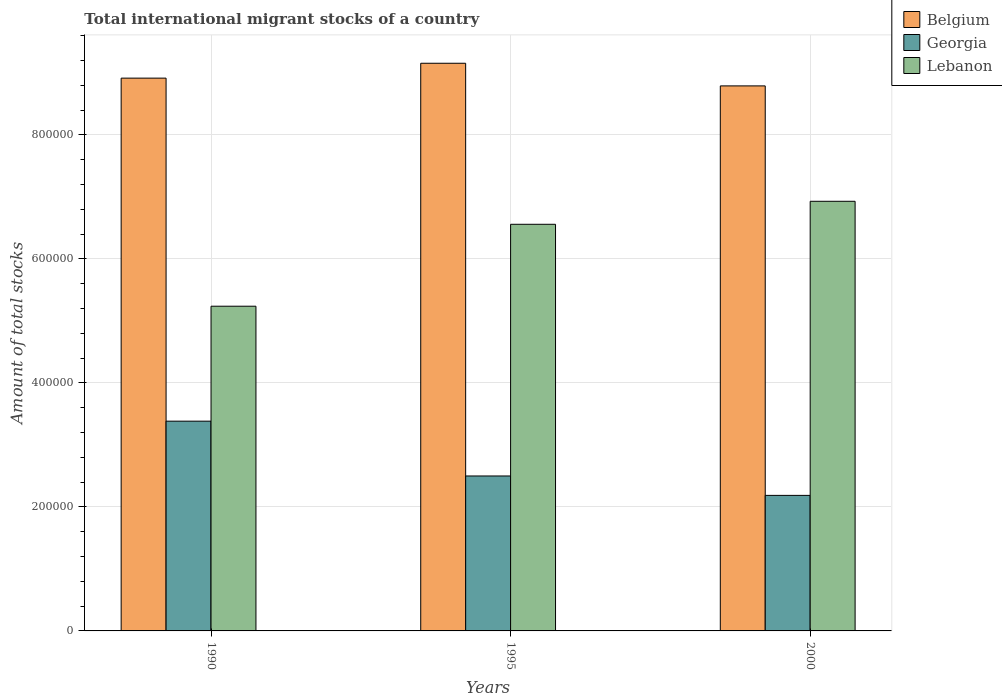Are the number of bars on each tick of the X-axis equal?
Your answer should be compact. Yes. How many bars are there on the 1st tick from the left?
Provide a succinct answer. 3. In how many cases, is the number of bars for a given year not equal to the number of legend labels?
Provide a short and direct response. 0. What is the amount of total stocks in in Georgia in 1995?
Your answer should be compact. 2.50e+05. Across all years, what is the maximum amount of total stocks in in Belgium?
Ensure brevity in your answer.  9.16e+05. Across all years, what is the minimum amount of total stocks in in Georgia?
Give a very brief answer. 2.19e+05. What is the total amount of total stocks in in Belgium in the graph?
Your answer should be compact. 2.69e+06. What is the difference between the amount of total stocks in in Belgium in 1990 and that in 1995?
Offer a very short reply. -2.40e+04. What is the difference between the amount of total stocks in in Lebanon in 1995 and the amount of total stocks in in Belgium in 1990?
Your response must be concise. -2.36e+05. What is the average amount of total stocks in in Lebanon per year?
Ensure brevity in your answer.  6.24e+05. In the year 2000, what is the difference between the amount of total stocks in in Belgium and amount of total stocks in in Georgia?
Your answer should be compact. 6.60e+05. What is the ratio of the amount of total stocks in in Lebanon in 1995 to that in 2000?
Offer a terse response. 0.95. Is the amount of total stocks in in Lebanon in 1995 less than that in 2000?
Ensure brevity in your answer.  Yes. What is the difference between the highest and the second highest amount of total stocks in in Belgium?
Provide a short and direct response. 2.40e+04. What is the difference between the highest and the lowest amount of total stocks in in Belgium?
Offer a terse response. 3.65e+04. In how many years, is the amount of total stocks in in Lebanon greater than the average amount of total stocks in in Lebanon taken over all years?
Your answer should be very brief. 2. What does the 2nd bar from the right in 2000 represents?
Your answer should be very brief. Georgia. How many bars are there?
Offer a very short reply. 9. Are the values on the major ticks of Y-axis written in scientific E-notation?
Your answer should be very brief. No. Does the graph contain any zero values?
Your response must be concise. No. How many legend labels are there?
Ensure brevity in your answer.  3. How are the legend labels stacked?
Give a very brief answer. Vertical. What is the title of the graph?
Your answer should be very brief. Total international migrant stocks of a country. Does "St. Vincent and the Grenadines" appear as one of the legend labels in the graph?
Provide a succinct answer. No. What is the label or title of the Y-axis?
Provide a succinct answer. Amount of total stocks. What is the Amount of total stocks in Belgium in 1990?
Keep it short and to the point. 8.92e+05. What is the Amount of total stocks of Georgia in 1990?
Provide a succinct answer. 3.38e+05. What is the Amount of total stocks in Lebanon in 1990?
Provide a short and direct response. 5.24e+05. What is the Amount of total stocks in Belgium in 1995?
Ensure brevity in your answer.  9.16e+05. What is the Amount of total stocks in Georgia in 1995?
Offer a very short reply. 2.50e+05. What is the Amount of total stocks of Lebanon in 1995?
Give a very brief answer. 6.56e+05. What is the Amount of total stocks of Belgium in 2000?
Your answer should be very brief. 8.79e+05. What is the Amount of total stocks of Georgia in 2000?
Give a very brief answer. 2.19e+05. What is the Amount of total stocks of Lebanon in 2000?
Make the answer very short. 6.93e+05. Across all years, what is the maximum Amount of total stocks in Belgium?
Keep it short and to the point. 9.16e+05. Across all years, what is the maximum Amount of total stocks of Georgia?
Provide a short and direct response. 3.38e+05. Across all years, what is the maximum Amount of total stocks in Lebanon?
Offer a very short reply. 6.93e+05. Across all years, what is the minimum Amount of total stocks in Belgium?
Ensure brevity in your answer.  8.79e+05. Across all years, what is the minimum Amount of total stocks in Georgia?
Your response must be concise. 2.19e+05. Across all years, what is the minimum Amount of total stocks in Lebanon?
Your response must be concise. 5.24e+05. What is the total Amount of total stocks in Belgium in the graph?
Ensure brevity in your answer.  2.69e+06. What is the total Amount of total stocks in Georgia in the graph?
Give a very brief answer. 8.07e+05. What is the total Amount of total stocks in Lebanon in the graph?
Provide a succinct answer. 1.87e+06. What is the difference between the Amount of total stocks in Belgium in 1990 and that in 1995?
Provide a short and direct response. -2.40e+04. What is the difference between the Amount of total stocks in Georgia in 1990 and that in 1995?
Your answer should be compact. 8.84e+04. What is the difference between the Amount of total stocks of Lebanon in 1990 and that in 1995?
Keep it short and to the point. -1.32e+05. What is the difference between the Amount of total stocks in Belgium in 1990 and that in 2000?
Offer a terse response. 1.25e+04. What is the difference between the Amount of total stocks in Georgia in 1990 and that in 2000?
Make the answer very short. 1.20e+05. What is the difference between the Amount of total stocks of Lebanon in 1990 and that in 2000?
Your answer should be very brief. -1.69e+05. What is the difference between the Amount of total stocks in Belgium in 1995 and that in 2000?
Your answer should be very brief. 3.65e+04. What is the difference between the Amount of total stocks of Georgia in 1995 and that in 2000?
Your answer should be very brief. 3.13e+04. What is the difference between the Amount of total stocks in Lebanon in 1995 and that in 2000?
Provide a succinct answer. -3.71e+04. What is the difference between the Amount of total stocks of Belgium in 1990 and the Amount of total stocks of Georgia in 1995?
Provide a succinct answer. 6.42e+05. What is the difference between the Amount of total stocks in Belgium in 1990 and the Amount of total stocks in Lebanon in 1995?
Ensure brevity in your answer.  2.36e+05. What is the difference between the Amount of total stocks in Georgia in 1990 and the Amount of total stocks in Lebanon in 1995?
Your answer should be compact. -3.18e+05. What is the difference between the Amount of total stocks of Belgium in 1990 and the Amount of total stocks of Georgia in 2000?
Provide a succinct answer. 6.73e+05. What is the difference between the Amount of total stocks of Belgium in 1990 and the Amount of total stocks of Lebanon in 2000?
Your answer should be compact. 1.99e+05. What is the difference between the Amount of total stocks of Georgia in 1990 and the Amount of total stocks of Lebanon in 2000?
Keep it short and to the point. -3.55e+05. What is the difference between the Amount of total stocks of Belgium in 1995 and the Amount of total stocks of Georgia in 2000?
Give a very brief answer. 6.97e+05. What is the difference between the Amount of total stocks in Belgium in 1995 and the Amount of total stocks in Lebanon in 2000?
Offer a very short reply. 2.23e+05. What is the difference between the Amount of total stocks of Georgia in 1995 and the Amount of total stocks of Lebanon in 2000?
Provide a succinct answer. -4.43e+05. What is the average Amount of total stocks of Belgium per year?
Your answer should be compact. 8.95e+05. What is the average Amount of total stocks of Georgia per year?
Make the answer very short. 2.69e+05. What is the average Amount of total stocks in Lebanon per year?
Offer a terse response. 6.24e+05. In the year 1990, what is the difference between the Amount of total stocks of Belgium and Amount of total stocks of Georgia?
Offer a terse response. 5.53e+05. In the year 1990, what is the difference between the Amount of total stocks of Belgium and Amount of total stocks of Lebanon?
Your answer should be very brief. 3.68e+05. In the year 1990, what is the difference between the Amount of total stocks in Georgia and Amount of total stocks in Lebanon?
Provide a succinct answer. -1.85e+05. In the year 1995, what is the difference between the Amount of total stocks in Belgium and Amount of total stocks in Georgia?
Provide a short and direct response. 6.66e+05. In the year 1995, what is the difference between the Amount of total stocks of Belgium and Amount of total stocks of Lebanon?
Keep it short and to the point. 2.60e+05. In the year 1995, what is the difference between the Amount of total stocks in Georgia and Amount of total stocks in Lebanon?
Offer a very short reply. -4.06e+05. In the year 2000, what is the difference between the Amount of total stocks in Belgium and Amount of total stocks in Georgia?
Keep it short and to the point. 6.60e+05. In the year 2000, what is the difference between the Amount of total stocks in Belgium and Amount of total stocks in Lebanon?
Keep it short and to the point. 1.86e+05. In the year 2000, what is the difference between the Amount of total stocks in Georgia and Amount of total stocks in Lebanon?
Offer a very short reply. -4.74e+05. What is the ratio of the Amount of total stocks in Belgium in 1990 to that in 1995?
Offer a very short reply. 0.97. What is the ratio of the Amount of total stocks of Georgia in 1990 to that in 1995?
Ensure brevity in your answer.  1.35. What is the ratio of the Amount of total stocks in Lebanon in 1990 to that in 1995?
Your response must be concise. 0.8. What is the ratio of the Amount of total stocks of Belgium in 1990 to that in 2000?
Your response must be concise. 1.01. What is the ratio of the Amount of total stocks of Georgia in 1990 to that in 2000?
Provide a short and direct response. 1.55. What is the ratio of the Amount of total stocks in Lebanon in 1990 to that in 2000?
Provide a succinct answer. 0.76. What is the ratio of the Amount of total stocks in Belgium in 1995 to that in 2000?
Give a very brief answer. 1.04. What is the ratio of the Amount of total stocks in Georgia in 1995 to that in 2000?
Your response must be concise. 1.14. What is the ratio of the Amount of total stocks in Lebanon in 1995 to that in 2000?
Provide a short and direct response. 0.95. What is the difference between the highest and the second highest Amount of total stocks in Belgium?
Keep it short and to the point. 2.40e+04. What is the difference between the highest and the second highest Amount of total stocks of Georgia?
Your response must be concise. 8.84e+04. What is the difference between the highest and the second highest Amount of total stocks of Lebanon?
Provide a succinct answer. 3.71e+04. What is the difference between the highest and the lowest Amount of total stocks in Belgium?
Offer a terse response. 3.65e+04. What is the difference between the highest and the lowest Amount of total stocks of Georgia?
Offer a terse response. 1.20e+05. What is the difference between the highest and the lowest Amount of total stocks in Lebanon?
Give a very brief answer. 1.69e+05. 